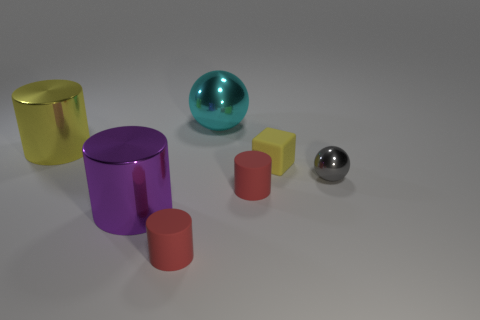Subtract all cyan cylinders. Subtract all blue balls. How many cylinders are left? 4 Add 1 small yellow shiny balls. How many objects exist? 8 Subtract all blocks. How many objects are left? 6 Add 4 tiny rubber things. How many tiny rubber things exist? 7 Subtract 0 blue cubes. How many objects are left? 7 Subtract all big metallic objects. Subtract all tiny metal balls. How many objects are left? 3 Add 2 large purple metal things. How many large purple metal things are left? 3 